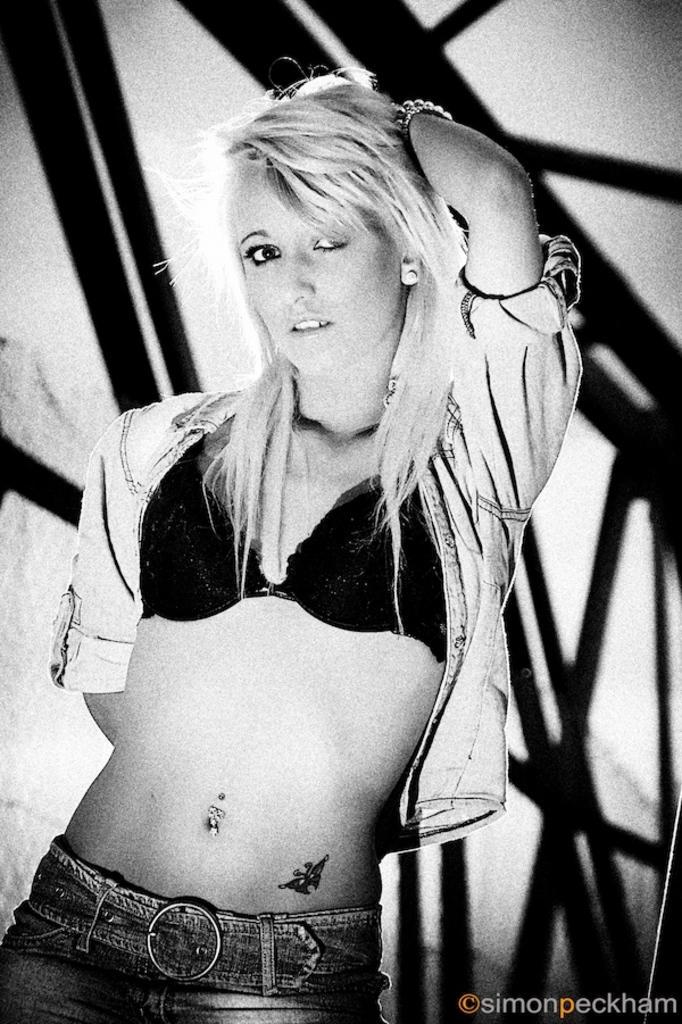Please provide a concise description of this image. In this image I can see the person with the dress. In the background I can see some metal rods and this is a black and white image. 